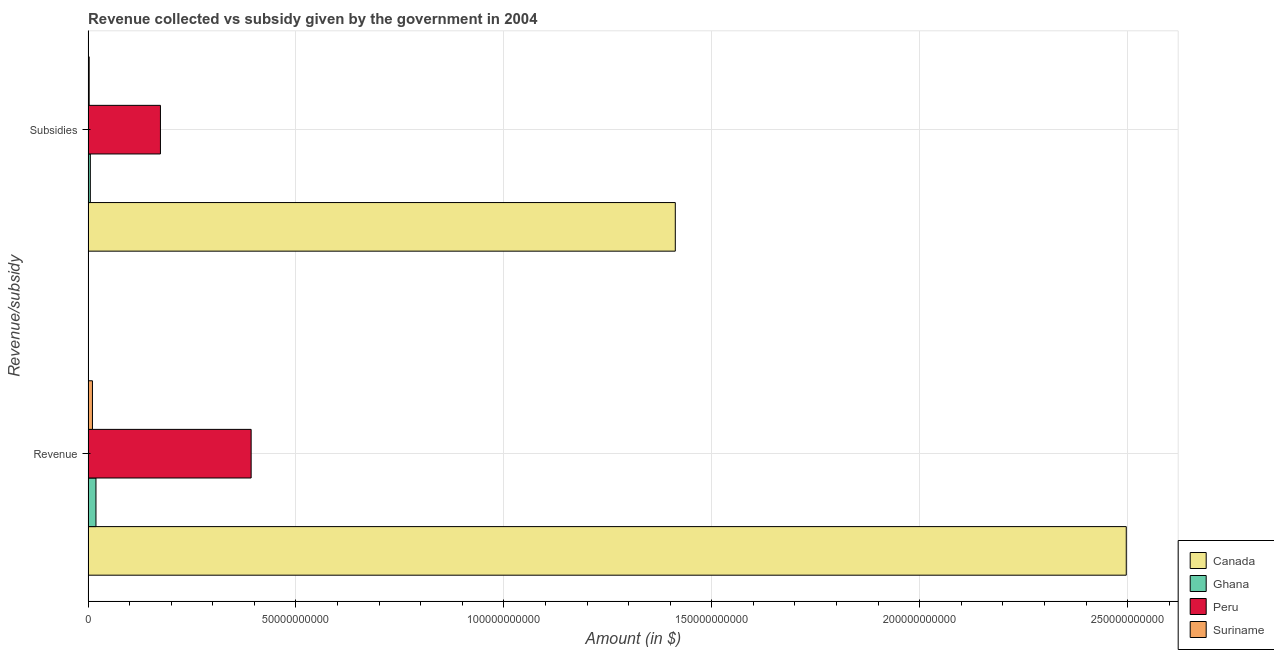How many groups of bars are there?
Offer a very short reply. 2. Are the number of bars per tick equal to the number of legend labels?
Offer a terse response. Yes. How many bars are there on the 2nd tick from the top?
Provide a succinct answer. 4. What is the label of the 1st group of bars from the top?
Provide a short and direct response. Subsidies. What is the amount of subsidies given in Peru?
Offer a terse response. 1.74e+1. Across all countries, what is the maximum amount of revenue collected?
Make the answer very short. 2.50e+11. Across all countries, what is the minimum amount of revenue collected?
Provide a succinct answer. 1.05e+09. In which country was the amount of revenue collected maximum?
Your answer should be very brief. Canada. In which country was the amount of subsidies given minimum?
Provide a short and direct response. Suriname. What is the total amount of subsidies given in the graph?
Your response must be concise. 1.59e+11. What is the difference between the amount of subsidies given in Ghana and that in Canada?
Give a very brief answer. -1.41e+11. What is the difference between the amount of subsidies given in Suriname and the amount of revenue collected in Peru?
Keep it short and to the point. -3.90e+1. What is the average amount of subsidies given per country?
Your answer should be compact. 3.99e+1. What is the difference between the amount of subsidies given and amount of revenue collected in Canada?
Provide a succinct answer. -1.08e+11. What is the ratio of the amount of revenue collected in Ghana to that in Peru?
Provide a short and direct response. 0.05. Is the amount of revenue collected in Ghana less than that in Canada?
Provide a short and direct response. Yes. In how many countries, is the amount of subsidies given greater than the average amount of subsidies given taken over all countries?
Your answer should be very brief. 1. How many bars are there?
Your answer should be very brief. 8. Are the values on the major ticks of X-axis written in scientific E-notation?
Your answer should be compact. No. Does the graph contain any zero values?
Your response must be concise. No. Does the graph contain grids?
Keep it short and to the point. Yes. How many legend labels are there?
Offer a terse response. 4. What is the title of the graph?
Make the answer very short. Revenue collected vs subsidy given by the government in 2004. Does "Ukraine" appear as one of the legend labels in the graph?
Make the answer very short. No. What is the label or title of the X-axis?
Your answer should be compact. Amount (in $). What is the label or title of the Y-axis?
Give a very brief answer. Revenue/subsidy. What is the Amount (in $) of Canada in Revenue?
Your answer should be compact. 2.50e+11. What is the Amount (in $) of Ghana in Revenue?
Give a very brief answer. 1.89e+09. What is the Amount (in $) in Peru in Revenue?
Give a very brief answer. 3.92e+1. What is the Amount (in $) in Suriname in Revenue?
Your answer should be compact. 1.05e+09. What is the Amount (in $) of Canada in Subsidies?
Offer a very short reply. 1.41e+11. What is the Amount (in $) of Ghana in Subsidies?
Make the answer very short. 5.37e+08. What is the Amount (in $) of Peru in Subsidies?
Give a very brief answer. 1.74e+1. What is the Amount (in $) of Suriname in Subsidies?
Your response must be concise. 2.61e+08. Across all Revenue/subsidy, what is the maximum Amount (in $) in Canada?
Provide a short and direct response. 2.50e+11. Across all Revenue/subsidy, what is the maximum Amount (in $) in Ghana?
Your answer should be compact. 1.89e+09. Across all Revenue/subsidy, what is the maximum Amount (in $) in Peru?
Offer a very short reply. 3.92e+1. Across all Revenue/subsidy, what is the maximum Amount (in $) in Suriname?
Offer a terse response. 1.05e+09. Across all Revenue/subsidy, what is the minimum Amount (in $) of Canada?
Offer a very short reply. 1.41e+11. Across all Revenue/subsidy, what is the minimum Amount (in $) of Ghana?
Provide a succinct answer. 5.37e+08. Across all Revenue/subsidy, what is the minimum Amount (in $) in Peru?
Give a very brief answer. 1.74e+1. Across all Revenue/subsidy, what is the minimum Amount (in $) in Suriname?
Offer a very short reply. 2.61e+08. What is the total Amount (in $) of Canada in the graph?
Your answer should be very brief. 3.91e+11. What is the total Amount (in $) of Ghana in the graph?
Provide a short and direct response. 2.43e+09. What is the total Amount (in $) in Peru in the graph?
Ensure brevity in your answer.  5.66e+1. What is the total Amount (in $) in Suriname in the graph?
Give a very brief answer. 1.31e+09. What is the difference between the Amount (in $) of Canada in Revenue and that in Subsidies?
Offer a very short reply. 1.08e+11. What is the difference between the Amount (in $) of Ghana in Revenue and that in Subsidies?
Give a very brief answer. 1.36e+09. What is the difference between the Amount (in $) in Peru in Revenue and that in Subsidies?
Offer a terse response. 2.18e+1. What is the difference between the Amount (in $) in Suriname in Revenue and that in Subsidies?
Offer a very short reply. 7.88e+08. What is the difference between the Amount (in $) in Canada in Revenue and the Amount (in $) in Ghana in Subsidies?
Your answer should be compact. 2.49e+11. What is the difference between the Amount (in $) of Canada in Revenue and the Amount (in $) of Peru in Subsidies?
Keep it short and to the point. 2.32e+11. What is the difference between the Amount (in $) of Canada in Revenue and the Amount (in $) of Suriname in Subsidies?
Offer a terse response. 2.49e+11. What is the difference between the Amount (in $) in Ghana in Revenue and the Amount (in $) in Peru in Subsidies?
Offer a terse response. -1.55e+1. What is the difference between the Amount (in $) of Ghana in Revenue and the Amount (in $) of Suriname in Subsidies?
Provide a short and direct response. 1.63e+09. What is the difference between the Amount (in $) in Peru in Revenue and the Amount (in $) in Suriname in Subsidies?
Make the answer very short. 3.90e+1. What is the average Amount (in $) in Canada per Revenue/subsidy?
Make the answer very short. 1.95e+11. What is the average Amount (in $) of Ghana per Revenue/subsidy?
Make the answer very short. 1.22e+09. What is the average Amount (in $) of Peru per Revenue/subsidy?
Your answer should be compact. 2.83e+1. What is the average Amount (in $) in Suriname per Revenue/subsidy?
Your answer should be very brief. 6.54e+08. What is the difference between the Amount (in $) in Canada and Amount (in $) in Ghana in Revenue?
Your answer should be compact. 2.48e+11. What is the difference between the Amount (in $) of Canada and Amount (in $) of Peru in Revenue?
Your answer should be compact. 2.10e+11. What is the difference between the Amount (in $) in Canada and Amount (in $) in Suriname in Revenue?
Offer a terse response. 2.49e+11. What is the difference between the Amount (in $) in Ghana and Amount (in $) in Peru in Revenue?
Provide a succinct answer. -3.73e+1. What is the difference between the Amount (in $) of Ghana and Amount (in $) of Suriname in Revenue?
Ensure brevity in your answer.  8.46e+08. What is the difference between the Amount (in $) in Peru and Amount (in $) in Suriname in Revenue?
Provide a succinct answer. 3.82e+1. What is the difference between the Amount (in $) in Canada and Amount (in $) in Ghana in Subsidies?
Make the answer very short. 1.41e+11. What is the difference between the Amount (in $) of Canada and Amount (in $) of Peru in Subsidies?
Your answer should be very brief. 1.24e+11. What is the difference between the Amount (in $) of Canada and Amount (in $) of Suriname in Subsidies?
Your response must be concise. 1.41e+11. What is the difference between the Amount (in $) of Ghana and Amount (in $) of Peru in Subsidies?
Make the answer very short. -1.69e+1. What is the difference between the Amount (in $) in Ghana and Amount (in $) in Suriname in Subsidies?
Ensure brevity in your answer.  2.76e+08. What is the difference between the Amount (in $) in Peru and Amount (in $) in Suriname in Subsidies?
Provide a short and direct response. 1.71e+1. What is the ratio of the Amount (in $) of Canada in Revenue to that in Subsidies?
Your answer should be compact. 1.77. What is the ratio of the Amount (in $) of Ghana in Revenue to that in Subsidies?
Make the answer very short. 3.53. What is the ratio of the Amount (in $) in Peru in Revenue to that in Subsidies?
Offer a terse response. 2.25. What is the ratio of the Amount (in $) in Suriname in Revenue to that in Subsidies?
Offer a very short reply. 4.02. What is the difference between the highest and the second highest Amount (in $) in Canada?
Provide a succinct answer. 1.08e+11. What is the difference between the highest and the second highest Amount (in $) in Ghana?
Your response must be concise. 1.36e+09. What is the difference between the highest and the second highest Amount (in $) in Peru?
Keep it short and to the point. 2.18e+1. What is the difference between the highest and the second highest Amount (in $) in Suriname?
Offer a very short reply. 7.88e+08. What is the difference between the highest and the lowest Amount (in $) in Canada?
Your answer should be compact. 1.08e+11. What is the difference between the highest and the lowest Amount (in $) of Ghana?
Make the answer very short. 1.36e+09. What is the difference between the highest and the lowest Amount (in $) in Peru?
Your answer should be very brief. 2.18e+1. What is the difference between the highest and the lowest Amount (in $) in Suriname?
Make the answer very short. 7.88e+08. 